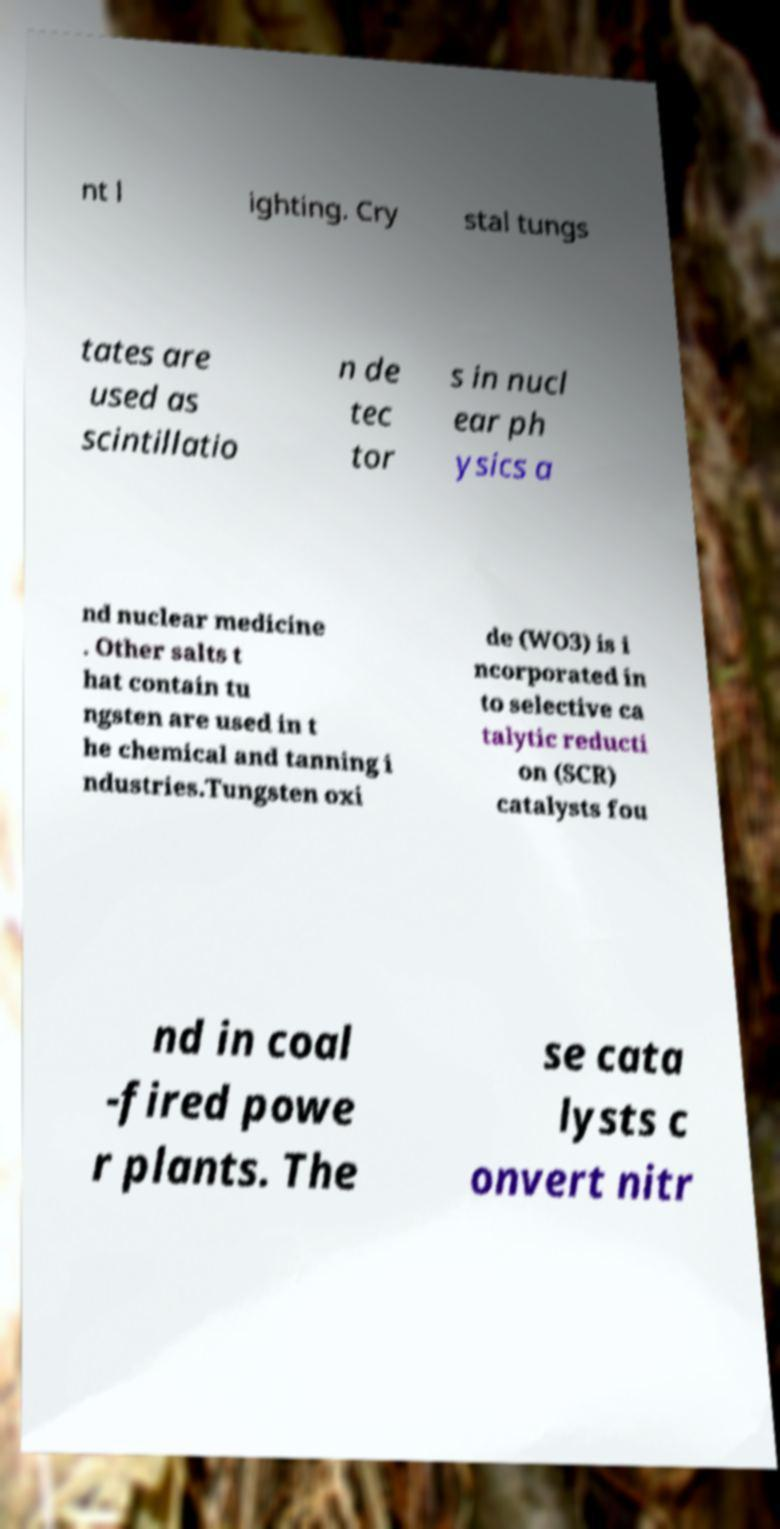Can you read and provide the text displayed in the image?This photo seems to have some interesting text. Can you extract and type it out for me? nt l ighting. Cry stal tungs tates are used as scintillatio n de tec tor s in nucl ear ph ysics a nd nuclear medicine . Other salts t hat contain tu ngsten are used in t he chemical and tanning i ndustries.Tungsten oxi de (WO3) is i ncorporated in to selective ca talytic reducti on (SCR) catalysts fou nd in coal -fired powe r plants. The se cata lysts c onvert nitr 